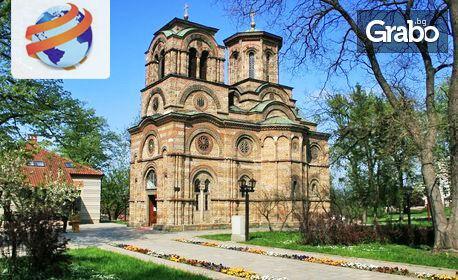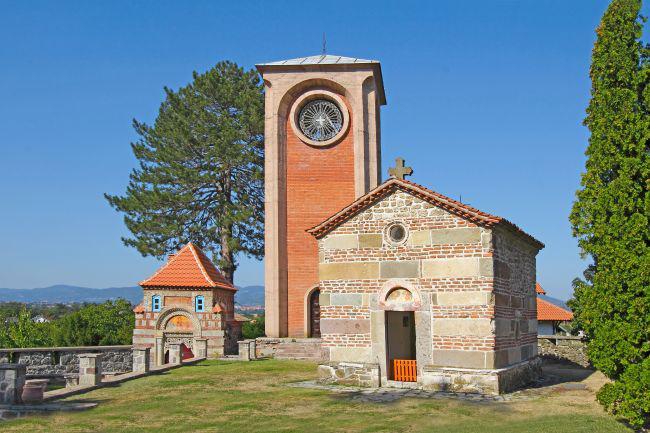The first image is the image on the left, the second image is the image on the right. For the images shown, is this caption "An ornate orange monastery has a rounded structure at one end with one central window with a curved top, and a small shed-like structure on at least one side." true? Answer yes or no. No. The first image is the image on the left, the second image is the image on the right. For the images shown, is this caption "Each image shows a red-orange building featuring a dome structure topped with a cross." true? Answer yes or no. No. 